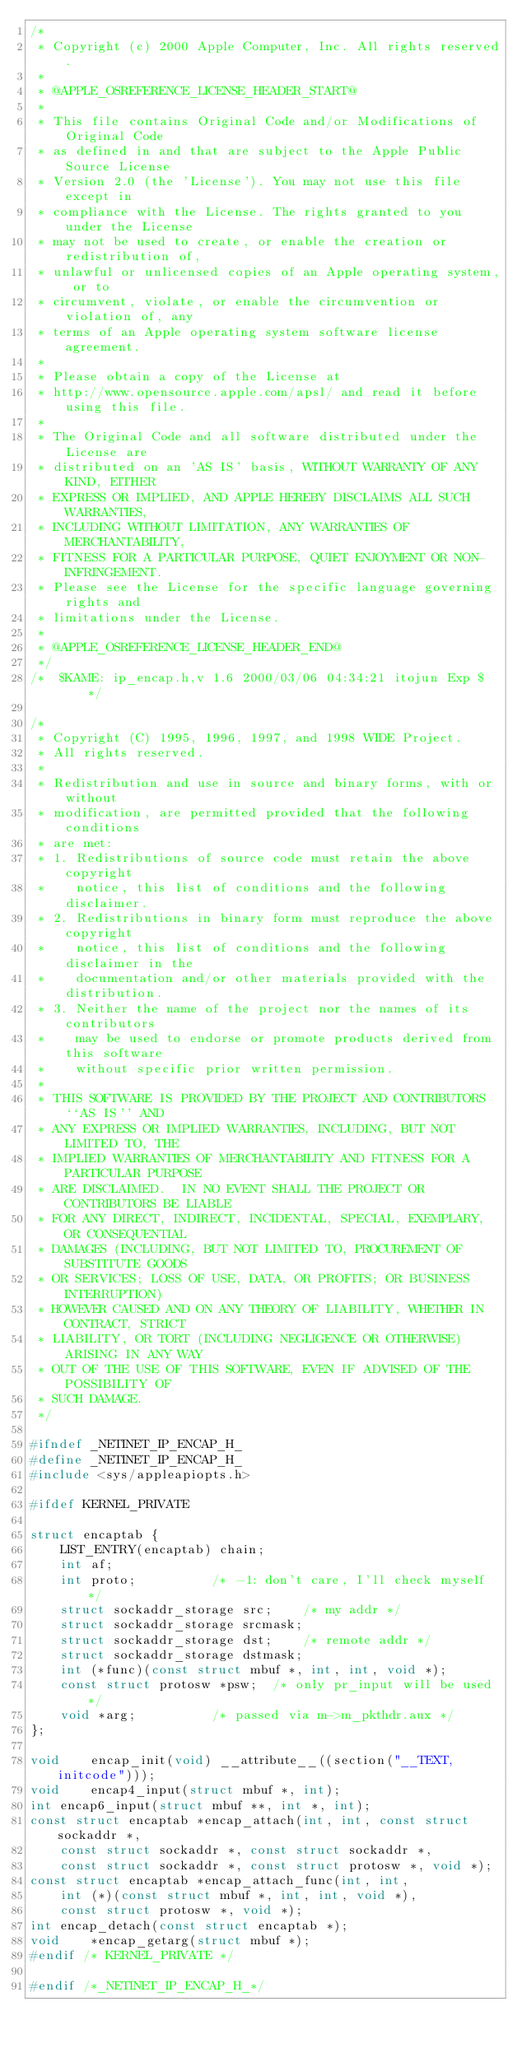Convert code to text. <code><loc_0><loc_0><loc_500><loc_500><_C_>/*
 * Copyright (c) 2000 Apple Computer, Inc. All rights reserved.
 *
 * @APPLE_OSREFERENCE_LICENSE_HEADER_START@
 * 
 * This file contains Original Code and/or Modifications of Original Code
 * as defined in and that are subject to the Apple Public Source License
 * Version 2.0 (the 'License'). You may not use this file except in
 * compliance with the License. The rights granted to you under the License
 * may not be used to create, or enable the creation or redistribution of,
 * unlawful or unlicensed copies of an Apple operating system, or to
 * circumvent, violate, or enable the circumvention or violation of, any
 * terms of an Apple operating system software license agreement.
 * 
 * Please obtain a copy of the License at
 * http://www.opensource.apple.com/apsl/ and read it before using this file.
 * 
 * The Original Code and all software distributed under the License are
 * distributed on an 'AS IS' basis, WITHOUT WARRANTY OF ANY KIND, EITHER
 * EXPRESS OR IMPLIED, AND APPLE HEREBY DISCLAIMS ALL SUCH WARRANTIES,
 * INCLUDING WITHOUT LIMITATION, ANY WARRANTIES OF MERCHANTABILITY,
 * FITNESS FOR A PARTICULAR PURPOSE, QUIET ENJOYMENT OR NON-INFRINGEMENT.
 * Please see the License for the specific language governing rights and
 * limitations under the License.
 * 
 * @APPLE_OSREFERENCE_LICENSE_HEADER_END@
 */
/*	$KAME: ip_encap.h,v 1.6 2000/03/06 04:34:21 itojun Exp $	*/

/*
 * Copyright (C) 1995, 1996, 1997, and 1998 WIDE Project.
 * All rights reserved.
 *
 * Redistribution and use in source and binary forms, with or without
 * modification, are permitted provided that the following conditions
 * are met:
 * 1. Redistributions of source code must retain the above copyright
 *    notice, this list of conditions and the following disclaimer.
 * 2. Redistributions in binary form must reproduce the above copyright
 *    notice, this list of conditions and the following disclaimer in the
 *    documentation and/or other materials provided with the distribution.
 * 3. Neither the name of the project nor the names of its contributors
 *    may be used to endorse or promote products derived from this software
 *    without specific prior written permission.
 *
 * THIS SOFTWARE IS PROVIDED BY THE PROJECT AND CONTRIBUTORS ``AS IS'' AND
 * ANY EXPRESS OR IMPLIED WARRANTIES, INCLUDING, BUT NOT LIMITED TO, THE
 * IMPLIED WARRANTIES OF MERCHANTABILITY AND FITNESS FOR A PARTICULAR PURPOSE
 * ARE DISCLAIMED.  IN NO EVENT SHALL THE PROJECT OR CONTRIBUTORS BE LIABLE
 * FOR ANY DIRECT, INDIRECT, INCIDENTAL, SPECIAL, EXEMPLARY, OR CONSEQUENTIAL
 * DAMAGES (INCLUDING, BUT NOT LIMITED TO, PROCUREMENT OF SUBSTITUTE GOODS
 * OR SERVICES; LOSS OF USE, DATA, OR PROFITS; OR BUSINESS INTERRUPTION)
 * HOWEVER CAUSED AND ON ANY THEORY OF LIABILITY, WHETHER IN CONTRACT, STRICT
 * LIABILITY, OR TORT (INCLUDING NEGLIGENCE OR OTHERWISE) ARISING IN ANY WAY
 * OUT OF THE USE OF THIS SOFTWARE, EVEN IF ADVISED OF THE POSSIBILITY OF
 * SUCH DAMAGE.
 */

#ifndef _NETINET_IP_ENCAP_H_
#define _NETINET_IP_ENCAP_H_
#include <sys/appleapiopts.h>

#ifdef KERNEL_PRIVATE

struct encaptab {
	LIST_ENTRY(encaptab) chain;
	int af;
	int proto;			/* -1: don't care, I'll check myself */
	struct sockaddr_storage src;	/* my addr */
	struct sockaddr_storage srcmask;
	struct sockaddr_storage dst;	/* remote addr */
	struct sockaddr_storage dstmask;
	int (*func)(const struct mbuf *, int, int, void *);
	const struct protosw *psw;	/* only pr_input will be used */
	void *arg;			/* passed via m->m_pkthdr.aux */
};

void	encap_init(void) __attribute__((section("__TEXT, initcode")));
void	encap4_input(struct mbuf *, int);
int	encap6_input(struct mbuf **, int *, int);
const struct encaptab *encap_attach(int, int, const struct sockaddr *,
	const struct sockaddr *, const struct sockaddr *,
	const struct sockaddr *, const struct protosw *, void *);
const struct encaptab *encap_attach_func(int, int,
	int (*)(const struct mbuf *, int, int, void *),
	const struct protosw *, void *);
int	encap_detach(const struct encaptab *);
void	*encap_getarg(struct mbuf *);
#endif /* KERNEL_PRIVATE */

#endif /*_NETINET_IP_ENCAP_H_*/
</code> 